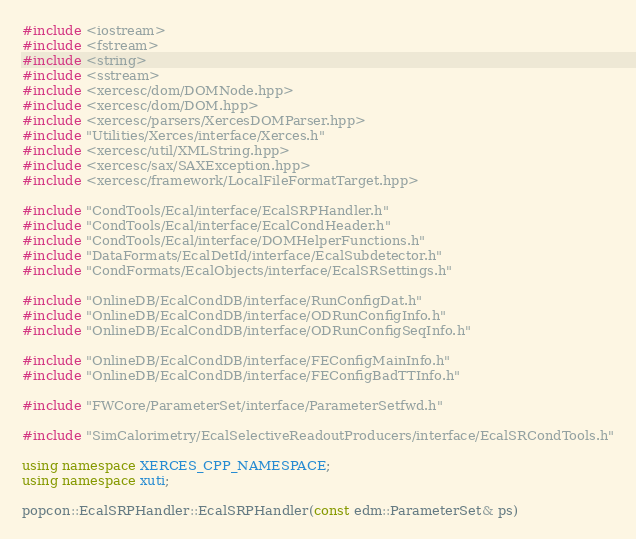Convert code to text. <code><loc_0><loc_0><loc_500><loc_500><_C++_>#include <iostream>
#include <fstream>
#include <string>
#include <sstream>
#include <xercesc/dom/DOMNode.hpp>
#include <xercesc/dom/DOM.hpp>
#include <xercesc/parsers/XercesDOMParser.hpp>
#include "Utilities/Xerces/interface/Xerces.h"
#include <xercesc/util/XMLString.hpp>
#include <xercesc/sax/SAXException.hpp>
#include <xercesc/framework/LocalFileFormatTarget.hpp>

#include "CondTools/Ecal/interface/EcalSRPHandler.h"
#include "CondTools/Ecal/interface/EcalCondHeader.h"
#include "CondTools/Ecal/interface/DOMHelperFunctions.h"
#include "DataFormats/EcalDetId/interface/EcalSubdetector.h"
#include "CondFormats/EcalObjects/interface/EcalSRSettings.h"

#include "OnlineDB/EcalCondDB/interface/RunConfigDat.h"
#include "OnlineDB/EcalCondDB/interface/ODRunConfigInfo.h"
#include "OnlineDB/EcalCondDB/interface/ODRunConfigSeqInfo.h"

#include "OnlineDB/EcalCondDB/interface/FEConfigMainInfo.h"
#include "OnlineDB/EcalCondDB/interface/FEConfigBadTTInfo.h"

#include "FWCore/ParameterSet/interface/ParameterSetfwd.h"

#include "SimCalorimetry/EcalSelectiveReadoutProducers/interface/EcalSRCondTools.h"

using namespace XERCES_CPP_NAMESPACE;
using namespace xuti;

popcon::EcalSRPHandler::EcalSRPHandler(const edm::ParameterSet& ps)</code> 